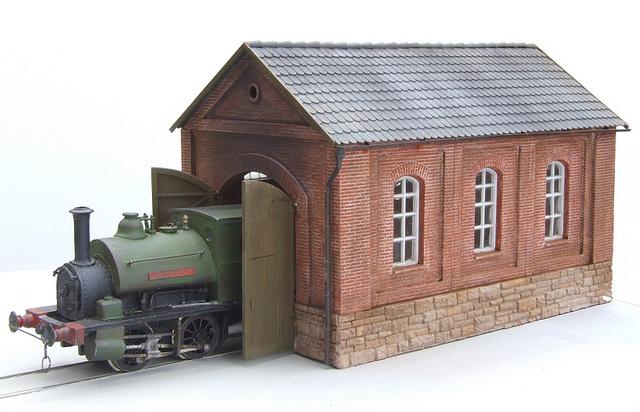What color is the train?
Keep it brief. Green. Is this an illustration?
Answer briefly. No. Is this a working train?
Short answer required. No. 